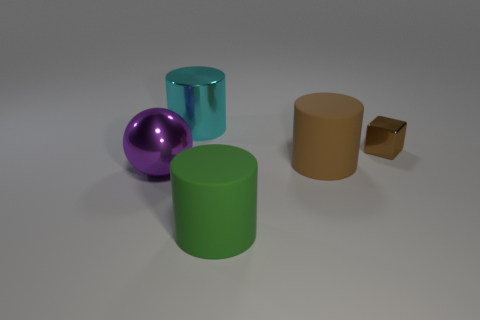Is the big cylinder that is right of the green cylinder made of the same material as the large cylinder that is on the left side of the big green thing?
Provide a short and direct response. No. There is a green thing that is the same shape as the brown matte thing; what is its material?
Your answer should be very brief. Rubber. Is there a cylinder of the same color as the metallic cube?
Your answer should be very brief. Yes. Is the big green thing made of the same material as the purple thing?
Provide a short and direct response. No. There is a brown metallic cube; what number of small brown cubes are on the left side of it?
Your answer should be compact. 0. What material is the cylinder that is on the left side of the brown rubber cylinder and in front of the brown block?
Your answer should be compact. Rubber. What number of blocks have the same size as the metal cylinder?
Keep it short and to the point. 0. What is the color of the matte cylinder behind the large sphere in front of the large shiny cylinder?
Offer a terse response. Brown. Is there a large purple object?
Offer a very short reply. Yes. Is the shape of the big cyan object the same as the brown rubber thing?
Ensure brevity in your answer.  Yes. 